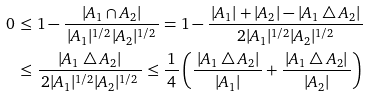Convert formula to latex. <formula><loc_0><loc_0><loc_500><loc_500>0 & \, \leq 1 - \frac { | A _ { 1 } \cap A _ { 2 } | } { \, | A _ { 1 } | ^ { 1 / 2 } | A _ { 2 } | ^ { 1 / 2 } \, } = 1 - \frac { \, | A _ { 1 } | + | A _ { 2 } | - | A _ { 1 } \bigtriangleup A _ { 2 } | \, } { 2 | A _ { 1 } | ^ { 1 / 2 } | A _ { 2 } | ^ { 1 / 2 } } \\ & \, \leq \frac { | A _ { 1 } \bigtriangleup A _ { 2 } | } { \, 2 | A _ { 1 } | ^ { 1 / 2 } | A _ { 2 } | ^ { 1 / 2 } \, } \leq \frac { 1 } { \, 4 \, } \left ( \frac { \, | A _ { 1 } \bigtriangleup A _ { 2 } | \, } { | A _ { 1 } | } + \frac { \, | A _ { 1 } \bigtriangleup A _ { 2 } | \, } { | A _ { 2 } | } \right )</formula> 